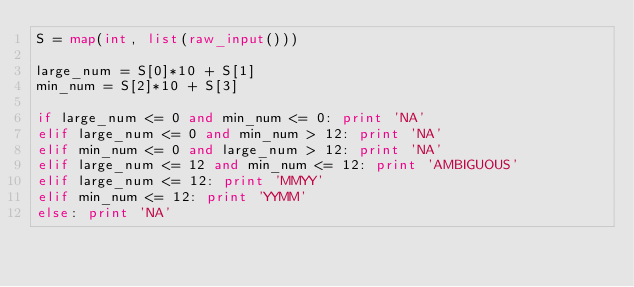<code> <loc_0><loc_0><loc_500><loc_500><_Python_>S = map(int, list(raw_input()))

large_num = S[0]*10 + S[1]
min_num = S[2]*10 + S[3]

if large_num <= 0 and min_num <= 0: print 'NA'
elif large_num <= 0 and min_num > 12: print 'NA'
elif min_num <= 0 and large_num > 12: print 'NA'
elif large_num <= 12 and min_num <= 12: print 'AMBIGUOUS'
elif large_num <= 12: print 'MMYY'
elif min_num <= 12: print 'YYMM'
else: print 'NA'</code> 